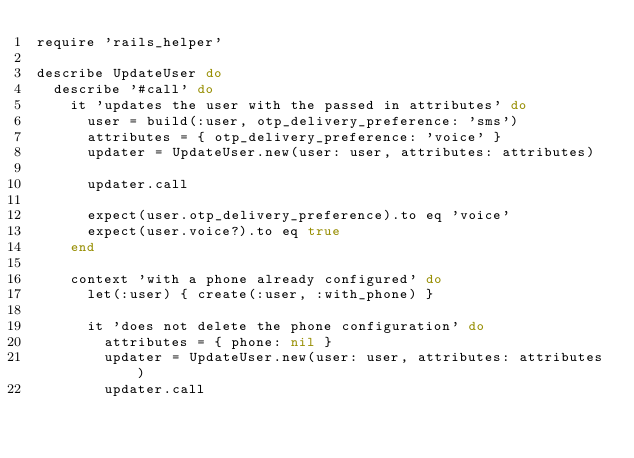Convert code to text. <code><loc_0><loc_0><loc_500><loc_500><_Ruby_>require 'rails_helper'

describe UpdateUser do
  describe '#call' do
    it 'updates the user with the passed in attributes' do
      user = build(:user, otp_delivery_preference: 'sms')
      attributes = { otp_delivery_preference: 'voice' }
      updater = UpdateUser.new(user: user, attributes: attributes)

      updater.call

      expect(user.otp_delivery_preference).to eq 'voice'
      expect(user.voice?).to eq true
    end

    context 'with a phone already configured' do
      let(:user) { create(:user, :with_phone) }

      it 'does not delete the phone configuration' do
        attributes = { phone: nil }
        updater = UpdateUser.new(user: user, attributes: attributes)
        updater.call</code> 